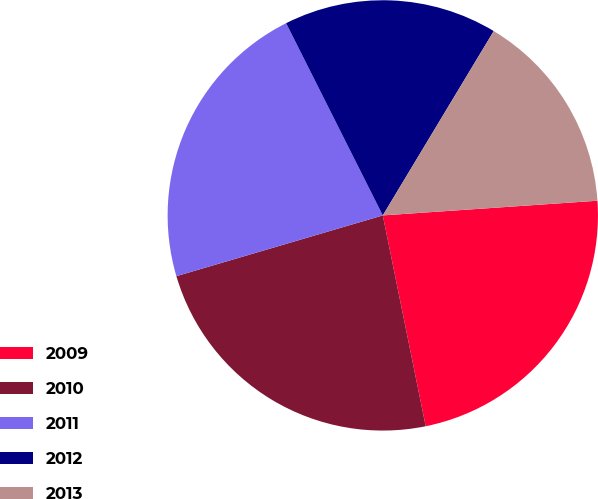Convert chart. <chart><loc_0><loc_0><loc_500><loc_500><pie_chart><fcel>2009<fcel>2010<fcel>2011<fcel>2012<fcel>2013<nl><fcel>22.89%<fcel>23.64%<fcel>22.14%<fcel>16.04%<fcel>15.29%<nl></chart> 